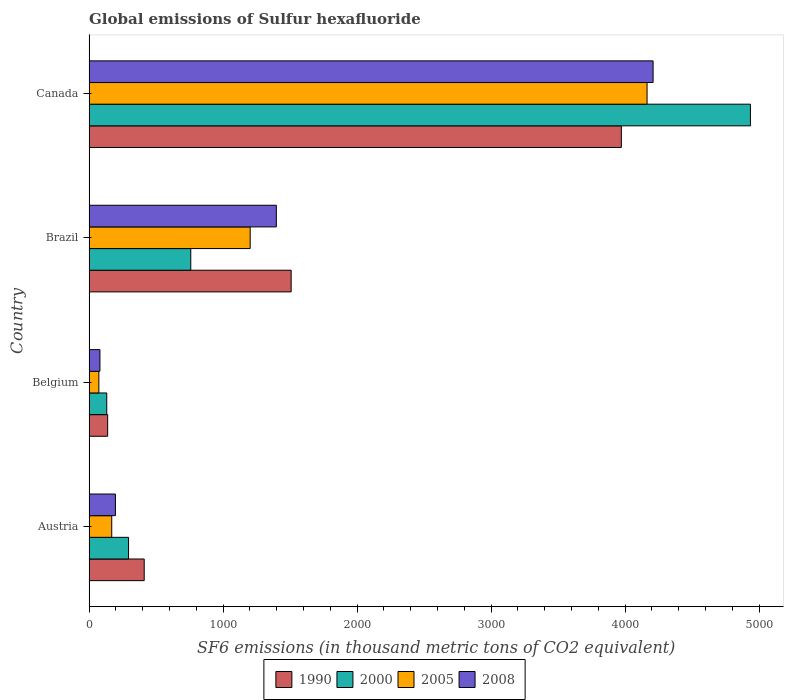How many groups of bars are there?
Your response must be concise. 4. Are the number of bars per tick equal to the number of legend labels?
Offer a terse response. Yes. How many bars are there on the 2nd tick from the bottom?
Offer a terse response. 4. What is the label of the 3rd group of bars from the top?
Make the answer very short. Belgium. In how many cases, is the number of bars for a given country not equal to the number of legend labels?
Provide a short and direct response. 0. What is the global emissions of Sulfur hexafluoride in 1990 in Austria?
Your answer should be compact. 411.2. Across all countries, what is the maximum global emissions of Sulfur hexafluoride in 1990?
Your answer should be compact. 3971.8. Across all countries, what is the minimum global emissions of Sulfur hexafluoride in 2008?
Offer a terse response. 80.9. In which country was the global emissions of Sulfur hexafluoride in 1990 minimum?
Provide a short and direct response. Belgium. What is the total global emissions of Sulfur hexafluoride in 1990 in the graph?
Offer a terse response. 6029.4. What is the difference between the global emissions of Sulfur hexafluoride in 2005 in Austria and that in Belgium?
Provide a succinct answer. 96.1. What is the difference between the global emissions of Sulfur hexafluoride in 2008 in Austria and the global emissions of Sulfur hexafluoride in 2005 in Canada?
Your answer should be very brief. -3967.4. What is the average global emissions of Sulfur hexafluoride in 1990 per country?
Ensure brevity in your answer.  1507.35. What is the difference between the global emissions of Sulfur hexafluoride in 1990 and global emissions of Sulfur hexafluoride in 2008 in Belgium?
Provide a succinct answer. 57.6. What is the ratio of the global emissions of Sulfur hexafluoride in 2000 in Belgium to that in Canada?
Give a very brief answer. 0.03. Is the global emissions of Sulfur hexafluoride in 2005 in Austria less than that in Brazil?
Your response must be concise. Yes. What is the difference between the highest and the second highest global emissions of Sulfur hexafluoride in 2005?
Your answer should be compact. 2961.8. What is the difference between the highest and the lowest global emissions of Sulfur hexafluoride in 2005?
Provide a short and direct response. 4090.9. Is the sum of the global emissions of Sulfur hexafluoride in 2005 in Brazil and Canada greater than the maximum global emissions of Sulfur hexafluoride in 2000 across all countries?
Offer a very short reply. Yes. Is it the case that in every country, the sum of the global emissions of Sulfur hexafluoride in 1990 and global emissions of Sulfur hexafluoride in 2000 is greater than the sum of global emissions of Sulfur hexafluoride in 2005 and global emissions of Sulfur hexafluoride in 2008?
Offer a terse response. No. What does the 1st bar from the top in Brazil represents?
Your answer should be compact. 2008. How many bars are there?
Your answer should be very brief. 16. Are all the bars in the graph horizontal?
Offer a terse response. Yes. What is the difference between two consecutive major ticks on the X-axis?
Keep it short and to the point. 1000. Does the graph contain grids?
Ensure brevity in your answer.  No. How are the legend labels stacked?
Offer a very short reply. Horizontal. What is the title of the graph?
Make the answer very short. Global emissions of Sulfur hexafluoride. What is the label or title of the X-axis?
Your answer should be compact. SF6 emissions (in thousand metric tons of CO2 equivalent). What is the SF6 emissions (in thousand metric tons of CO2 equivalent) of 1990 in Austria?
Your answer should be very brief. 411.2. What is the SF6 emissions (in thousand metric tons of CO2 equivalent) of 2000 in Austria?
Offer a very short reply. 294.4. What is the SF6 emissions (in thousand metric tons of CO2 equivalent) of 2005 in Austria?
Your answer should be compact. 169. What is the SF6 emissions (in thousand metric tons of CO2 equivalent) in 2008 in Austria?
Make the answer very short. 196.4. What is the SF6 emissions (in thousand metric tons of CO2 equivalent) of 1990 in Belgium?
Make the answer very short. 138.5. What is the SF6 emissions (in thousand metric tons of CO2 equivalent) of 2000 in Belgium?
Ensure brevity in your answer.  131.7. What is the SF6 emissions (in thousand metric tons of CO2 equivalent) of 2005 in Belgium?
Your response must be concise. 72.9. What is the SF6 emissions (in thousand metric tons of CO2 equivalent) of 2008 in Belgium?
Your response must be concise. 80.9. What is the SF6 emissions (in thousand metric tons of CO2 equivalent) in 1990 in Brazil?
Offer a very short reply. 1507.9. What is the SF6 emissions (in thousand metric tons of CO2 equivalent) of 2000 in Brazil?
Your answer should be very brief. 758.7. What is the SF6 emissions (in thousand metric tons of CO2 equivalent) in 2005 in Brazil?
Ensure brevity in your answer.  1202. What is the SF6 emissions (in thousand metric tons of CO2 equivalent) of 2008 in Brazil?
Offer a terse response. 1397.3. What is the SF6 emissions (in thousand metric tons of CO2 equivalent) in 1990 in Canada?
Offer a terse response. 3971.8. What is the SF6 emissions (in thousand metric tons of CO2 equivalent) of 2000 in Canada?
Your response must be concise. 4935.1. What is the SF6 emissions (in thousand metric tons of CO2 equivalent) of 2005 in Canada?
Give a very brief answer. 4163.8. What is the SF6 emissions (in thousand metric tons of CO2 equivalent) in 2008 in Canada?
Your answer should be very brief. 4208.8. Across all countries, what is the maximum SF6 emissions (in thousand metric tons of CO2 equivalent) in 1990?
Offer a terse response. 3971.8. Across all countries, what is the maximum SF6 emissions (in thousand metric tons of CO2 equivalent) of 2000?
Offer a very short reply. 4935.1. Across all countries, what is the maximum SF6 emissions (in thousand metric tons of CO2 equivalent) in 2005?
Offer a terse response. 4163.8. Across all countries, what is the maximum SF6 emissions (in thousand metric tons of CO2 equivalent) in 2008?
Give a very brief answer. 4208.8. Across all countries, what is the minimum SF6 emissions (in thousand metric tons of CO2 equivalent) of 1990?
Your answer should be compact. 138.5. Across all countries, what is the minimum SF6 emissions (in thousand metric tons of CO2 equivalent) of 2000?
Make the answer very short. 131.7. Across all countries, what is the minimum SF6 emissions (in thousand metric tons of CO2 equivalent) in 2005?
Your response must be concise. 72.9. Across all countries, what is the minimum SF6 emissions (in thousand metric tons of CO2 equivalent) in 2008?
Provide a succinct answer. 80.9. What is the total SF6 emissions (in thousand metric tons of CO2 equivalent) of 1990 in the graph?
Make the answer very short. 6029.4. What is the total SF6 emissions (in thousand metric tons of CO2 equivalent) of 2000 in the graph?
Your response must be concise. 6119.9. What is the total SF6 emissions (in thousand metric tons of CO2 equivalent) in 2005 in the graph?
Your response must be concise. 5607.7. What is the total SF6 emissions (in thousand metric tons of CO2 equivalent) in 2008 in the graph?
Offer a terse response. 5883.4. What is the difference between the SF6 emissions (in thousand metric tons of CO2 equivalent) of 1990 in Austria and that in Belgium?
Your answer should be compact. 272.7. What is the difference between the SF6 emissions (in thousand metric tons of CO2 equivalent) of 2000 in Austria and that in Belgium?
Offer a very short reply. 162.7. What is the difference between the SF6 emissions (in thousand metric tons of CO2 equivalent) of 2005 in Austria and that in Belgium?
Ensure brevity in your answer.  96.1. What is the difference between the SF6 emissions (in thousand metric tons of CO2 equivalent) of 2008 in Austria and that in Belgium?
Offer a terse response. 115.5. What is the difference between the SF6 emissions (in thousand metric tons of CO2 equivalent) of 1990 in Austria and that in Brazil?
Make the answer very short. -1096.7. What is the difference between the SF6 emissions (in thousand metric tons of CO2 equivalent) in 2000 in Austria and that in Brazil?
Provide a short and direct response. -464.3. What is the difference between the SF6 emissions (in thousand metric tons of CO2 equivalent) of 2005 in Austria and that in Brazil?
Your response must be concise. -1033. What is the difference between the SF6 emissions (in thousand metric tons of CO2 equivalent) in 2008 in Austria and that in Brazil?
Offer a very short reply. -1200.9. What is the difference between the SF6 emissions (in thousand metric tons of CO2 equivalent) of 1990 in Austria and that in Canada?
Ensure brevity in your answer.  -3560.6. What is the difference between the SF6 emissions (in thousand metric tons of CO2 equivalent) of 2000 in Austria and that in Canada?
Your answer should be compact. -4640.7. What is the difference between the SF6 emissions (in thousand metric tons of CO2 equivalent) in 2005 in Austria and that in Canada?
Keep it short and to the point. -3994.8. What is the difference between the SF6 emissions (in thousand metric tons of CO2 equivalent) of 2008 in Austria and that in Canada?
Your answer should be very brief. -4012.4. What is the difference between the SF6 emissions (in thousand metric tons of CO2 equivalent) of 1990 in Belgium and that in Brazil?
Your response must be concise. -1369.4. What is the difference between the SF6 emissions (in thousand metric tons of CO2 equivalent) in 2000 in Belgium and that in Brazil?
Provide a succinct answer. -627. What is the difference between the SF6 emissions (in thousand metric tons of CO2 equivalent) in 2005 in Belgium and that in Brazil?
Ensure brevity in your answer.  -1129.1. What is the difference between the SF6 emissions (in thousand metric tons of CO2 equivalent) of 2008 in Belgium and that in Brazil?
Keep it short and to the point. -1316.4. What is the difference between the SF6 emissions (in thousand metric tons of CO2 equivalent) in 1990 in Belgium and that in Canada?
Make the answer very short. -3833.3. What is the difference between the SF6 emissions (in thousand metric tons of CO2 equivalent) in 2000 in Belgium and that in Canada?
Offer a terse response. -4803.4. What is the difference between the SF6 emissions (in thousand metric tons of CO2 equivalent) of 2005 in Belgium and that in Canada?
Your response must be concise. -4090.9. What is the difference between the SF6 emissions (in thousand metric tons of CO2 equivalent) in 2008 in Belgium and that in Canada?
Ensure brevity in your answer.  -4127.9. What is the difference between the SF6 emissions (in thousand metric tons of CO2 equivalent) of 1990 in Brazil and that in Canada?
Offer a terse response. -2463.9. What is the difference between the SF6 emissions (in thousand metric tons of CO2 equivalent) in 2000 in Brazil and that in Canada?
Your response must be concise. -4176.4. What is the difference between the SF6 emissions (in thousand metric tons of CO2 equivalent) of 2005 in Brazil and that in Canada?
Keep it short and to the point. -2961.8. What is the difference between the SF6 emissions (in thousand metric tons of CO2 equivalent) in 2008 in Brazil and that in Canada?
Ensure brevity in your answer.  -2811.5. What is the difference between the SF6 emissions (in thousand metric tons of CO2 equivalent) in 1990 in Austria and the SF6 emissions (in thousand metric tons of CO2 equivalent) in 2000 in Belgium?
Your response must be concise. 279.5. What is the difference between the SF6 emissions (in thousand metric tons of CO2 equivalent) in 1990 in Austria and the SF6 emissions (in thousand metric tons of CO2 equivalent) in 2005 in Belgium?
Provide a short and direct response. 338.3. What is the difference between the SF6 emissions (in thousand metric tons of CO2 equivalent) in 1990 in Austria and the SF6 emissions (in thousand metric tons of CO2 equivalent) in 2008 in Belgium?
Provide a short and direct response. 330.3. What is the difference between the SF6 emissions (in thousand metric tons of CO2 equivalent) of 2000 in Austria and the SF6 emissions (in thousand metric tons of CO2 equivalent) of 2005 in Belgium?
Offer a terse response. 221.5. What is the difference between the SF6 emissions (in thousand metric tons of CO2 equivalent) of 2000 in Austria and the SF6 emissions (in thousand metric tons of CO2 equivalent) of 2008 in Belgium?
Make the answer very short. 213.5. What is the difference between the SF6 emissions (in thousand metric tons of CO2 equivalent) in 2005 in Austria and the SF6 emissions (in thousand metric tons of CO2 equivalent) in 2008 in Belgium?
Ensure brevity in your answer.  88.1. What is the difference between the SF6 emissions (in thousand metric tons of CO2 equivalent) in 1990 in Austria and the SF6 emissions (in thousand metric tons of CO2 equivalent) in 2000 in Brazil?
Provide a succinct answer. -347.5. What is the difference between the SF6 emissions (in thousand metric tons of CO2 equivalent) in 1990 in Austria and the SF6 emissions (in thousand metric tons of CO2 equivalent) in 2005 in Brazil?
Offer a terse response. -790.8. What is the difference between the SF6 emissions (in thousand metric tons of CO2 equivalent) of 1990 in Austria and the SF6 emissions (in thousand metric tons of CO2 equivalent) of 2008 in Brazil?
Give a very brief answer. -986.1. What is the difference between the SF6 emissions (in thousand metric tons of CO2 equivalent) of 2000 in Austria and the SF6 emissions (in thousand metric tons of CO2 equivalent) of 2005 in Brazil?
Ensure brevity in your answer.  -907.6. What is the difference between the SF6 emissions (in thousand metric tons of CO2 equivalent) in 2000 in Austria and the SF6 emissions (in thousand metric tons of CO2 equivalent) in 2008 in Brazil?
Provide a succinct answer. -1102.9. What is the difference between the SF6 emissions (in thousand metric tons of CO2 equivalent) of 2005 in Austria and the SF6 emissions (in thousand metric tons of CO2 equivalent) of 2008 in Brazil?
Give a very brief answer. -1228.3. What is the difference between the SF6 emissions (in thousand metric tons of CO2 equivalent) in 1990 in Austria and the SF6 emissions (in thousand metric tons of CO2 equivalent) in 2000 in Canada?
Keep it short and to the point. -4523.9. What is the difference between the SF6 emissions (in thousand metric tons of CO2 equivalent) in 1990 in Austria and the SF6 emissions (in thousand metric tons of CO2 equivalent) in 2005 in Canada?
Provide a succinct answer. -3752.6. What is the difference between the SF6 emissions (in thousand metric tons of CO2 equivalent) in 1990 in Austria and the SF6 emissions (in thousand metric tons of CO2 equivalent) in 2008 in Canada?
Keep it short and to the point. -3797.6. What is the difference between the SF6 emissions (in thousand metric tons of CO2 equivalent) of 2000 in Austria and the SF6 emissions (in thousand metric tons of CO2 equivalent) of 2005 in Canada?
Ensure brevity in your answer.  -3869.4. What is the difference between the SF6 emissions (in thousand metric tons of CO2 equivalent) in 2000 in Austria and the SF6 emissions (in thousand metric tons of CO2 equivalent) in 2008 in Canada?
Your response must be concise. -3914.4. What is the difference between the SF6 emissions (in thousand metric tons of CO2 equivalent) in 2005 in Austria and the SF6 emissions (in thousand metric tons of CO2 equivalent) in 2008 in Canada?
Provide a short and direct response. -4039.8. What is the difference between the SF6 emissions (in thousand metric tons of CO2 equivalent) in 1990 in Belgium and the SF6 emissions (in thousand metric tons of CO2 equivalent) in 2000 in Brazil?
Offer a terse response. -620.2. What is the difference between the SF6 emissions (in thousand metric tons of CO2 equivalent) of 1990 in Belgium and the SF6 emissions (in thousand metric tons of CO2 equivalent) of 2005 in Brazil?
Make the answer very short. -1063.5. What is the difference between the SF6 emissions (in thousand metric tons of CO2 equivalent) of 1990 in Belgium and the SF6 emissions (in thousand metric tons of CO2 equivalent) of 2008 in Brazil?
Offer a very short reply. -1258.8. What is the difference between the SF6 emissions (in thousand metric tons of CO2 equivalent) of 2000 in Belgium and the SF6 emissions (in thousand metric tons of CO2 equivalent) of 2005 in Brazil?
Ensure brevity in your answer.  -1070.3. What is the difference between the SF6 emissions (in thousand metric tons of CO2 equivalent) of 2000 in Belgium and the SF6 emissions (in thousand metric tons of CO2 equivalent) of 2008 in Brazil?
Offer a terse response. -1265.6. What is the difference between the SF6 emissions (in thousand metric tons of CO2 equivalent) of 2005 in Belgium and the SF6 emissions (in thousand metric tons of CO2 equivalent) of 2008 in Brazil?
Your answer should be very brief. -1324.4. What is the difference between the SF6 emissions (in thousand metric tons of CO2 equivalent) of 1990 in Belgium and the SF6 emissions (in thousand metric tons of CO2 equivalent) of 2000 in Canada?
Your answer should be very brief. -4796.6. What is the difference between the SF6 emissions (in thousand metric tons of CO2 equivalent) of 1990 in Belgium and the SF6 emissions (in thousand metric tons of CO2 equivalent) of 2005 in Canada?
Your response must be concise. -4025.3. What is the difference between the SF6 emissions (in thousand metric tons of CO2 equivalent) in 1990 in Belgium and the SF6 emissions (in thousand metric tons of CO2 equivalent) in 2008 in Canada?
Keep it short and to the point. -4070.3. What is the difference between the SF6 emissions (in thousand metric tons of CO2 equivalent) of 2000 in Belgium and the SF6 emissions (in thousand metric tons of CO2 equivalent) of 2005 in Canada?
Make the answer very short. -4032.1. What is the difference between the SF6 emissions (in thousand metric tons of CO2 equivalent) in 2000 in Belgium and the SF6 emissions (in thousand metric tons of CO2 equivalent) in 2008 in Canada?
Ensure brevity in your answer.  -4077.1. What is the difference between the SF6 emissions (in thousand metric tons of CO2 equivalent) of 2005 in Belgium and the SF6 emissions (in thousand metric tons of CO2 equivalent) of 2008 in Canada?
Ensure brevity in your answer.  -4135.9. What is the difference between the SF6 emissions (in thousand metric tons of CO2 equivalent) of 1990 in Brazil and the SF6 emissions (in thousand metric tons of CO2 equivalent) of 2000 in Canada?
Ensure brevity in your answer.  -3427.2. What is the difference between the SF6 emissions (in thousand metric tons of CO2 equivalent) of 1990 in Brazil and the SF6 emissions (in thousand metric tons of CO2 equivalent) of 2005 in Canada?
Make the answer very short. -2655.9. What is the difference between the SF6 emissions (in thousand metric tons of CO2 equivalent) in 1990 in Brazil and the SF6 emissions (in thousand metric tons of CO2 equivalent) in 2008 in Canada?
Your answer should be very brief. -2700.9. What is the difference between the SF6 emissions (in thousand metric tons of CO2 equivalent) of 2000 in Brazil and the SF6 emissions (in thousand metric tons of CO2 equivalent) of 2005 in Canada?
Keep it short and to the point. -3405.1. What is the difference between the SF6 emissions (in thousand metric tons of CO2 equivalent) of 2000 in Brazil and the SF6 emissions (in thousand metric tons of CO2 equivalent) of 2008 in Canada?
Make the answer very short. -3450.1. What is the difference between the SF6 emissions (in thousand metric tons of CO2 equivalent) in 2005 in Brazil and the SF6 emissions (in thousand metric tons of CO2 equivalent) in 2008 in Canada?
Keep it short and to the point. -3006.8. What is the average SF6 emissions (in thousand metric tons of CO2 equivalent) in 1990 per country?
Ensure brevity in your answer.  1507.35. What is the average SF6 emissions (in thousand metric tons of CO2 equivalent) in 2000 per country?
Provide a short and direct response. 1529.97. What is the average SF6 emissions (in thousand metric tons of CO2 equivalent) in 2005 per country?
Your answer should be compact. 1401.92. What is the average SF6 emissions (in thousand metric tons of CO2 equivalent) in 2008 per country?
Your answer should be compact. 1470.85. What is the difference between the SF6 emissions (in thousand metric tons of CO2 equivalent) in 1990 and SF6 emissions (in thousand metric tons of CO2 equivalent) in 2000 in Austria?
Offer a terse response. 116.8. What is the difference between the SF6 emissions (in thousand metric tons of CO2 equivalent) of 1990 and SF6 emissions (in thousand metric tons of CO2 equivalent) of 2005 in Austria?
Provide a short and direct response. 242.2. What is the difference between the SF6 emissions (in thousand metric tons of CO2 equivalent) of 1990 and SF6 emissions (in thousand metric tons of CO2 equivalent) of 2008 in Austria?
Provide a succinct answer. 214.8. What is the difference between the SF6 emissions (in thousand metric tons of CO2 equivalent) in 2000 and SF6 emissions (in thousand metric tons of CO2 equivalent) in 2005 in Austria?
Offer a terse response. 125.4. What is the difference between the SF6 emissions (in thousand metric tons of CO2 equivalent) of 2000 and SF6 emissions (in thousand metric tons of CO2 equivalent) of 2008 in Austria?
Provide a succinct answer. 98. What is the difference between the SF6 emissions (in thousand metric tons of CO2 equivalent) in 2005 and SF6 emissions (in thousand metric tons of CO2 equivalent) in 2008 in Austria?
Offer a terse response. -27.4. What is the difference between the SF6 emissions (in thousand metric tons of CO2 equivalent) in 1990 and SF6 emissions (in thousand metric tons of CO2 equivalent) in 2005 in Belgium?
Your answer should be very brief. 65.6. What is the difference between the SF6 emissions (in thousand metric tons of CO2 equivalent) in 1990 and SF6 emissions (in thousand metric tons of CO2 equivalent) in 2008 in Belgium?
Offer a very short reply. 57.6. What is the difference between the SF6 emissions (in thousand metric tons of CO2 equivalent) of 2000 and SF6 emissions (in thousand metric tons of CO2 equivalent) of 2005 in Belgium?
Offer a very short reply. 58.8. What is the difference between the SF6 emissions (in thousand metric tons of CO2 equivalent) of 2000 and SF6 emissions (in thousand metric tons of CO2 equivalent) of 2008 in Belgium?
Ensure brevity in your answer.  50.8. What is the difference between the SF6 emissions (in thousand metric tons of CO2 equivalent) of 2005 and SF6 emissions (in thousand metric tons of CO2 equivalent) of 2008 in Belgium?
Provide a short and direct response. -8. What is the difference between the SF6 emissions (in thousand metric tons of CO2 equivalent) in 1990 and SF6 emissions (in thousand metric tons of CO2 equivalent) in 2000 in Brazil?
Keep it short and to the point. 749.2. What is the difference between the SF6 emissions (in thousand metric tons of CO2 equivalent) of 1990 and SF6 emissions (in thousand metric tons of CO2 equivalent) of 2005 in Brazil?
Provide a short and direct response. 305.9. What is the difference between the SF6 emissions (in thousand metric tons of CO2 equivalent) of 1990 and SF6 emissions (in thousand metric tons of CO2 equivalent) of 2008 in Brazil?
Keep it short and to the point. 110.6. What is the difference between the SF6 emissions (in thousand metric tons of CO2 equivalent) in 2000 and SF6 emissions (in thousand metric tons of CO2 equivalent) in 2005 in Brazil?
Make the answer very short. -443.3. What is the difference between the SF6 emissions (in thousand metric tons of CO2 equivalent) in 2000 and SF6 emissions (in thousand metric tons of CO2 equivalent) in 2008 in Brazil?
Keep it short and to the point. -638.6. What is the difference between the SF6 emissions (in thousand metric tons of CO2 equivalent) of 2005 and SF6 emissions (in thousand metric tons of CO2 equivalent) of 2008 in Brazil?
Your answer should be very brief. -195.3. What is the difference between the SF6 emissions (in thousand metric tons of CO2 equivalent) of 1990 and SF6 emissions (in thousand metric tons of CO2 equivalent) of 2000 in Canada?
Make the answer very short. -963.3. What is the difference between the SF6 emissions (in thousand metric tons of CO2 equivalent) in 1990 and SF6 emissions (in thousand metric tons of CO2 equivalent) in 2005 in Canada?
Offer a terse response. -192. What is the difference between the SF6 emissions (in thousand metric tons of CO2 equivalent) in 1990 and SF6 emissions (in thousand metric tons of CO2 equivalent) in 2008 in Canada?
Give a very brief answer. -237. What is the difference between the SF6 emissions (in thousand metric tons of CO2 equivalent) of 2000 and SF6 emissions (in thousand metric tons of CO2 equivalent) of 2005 in Canada?
Make the answer very short. 771.3. What is the difference between the SF6 emissions (in thousand metric tons of CO2 equivalent) of 2000 and SF6 emissions (in thousand metric tons of CO2 equivalent) of 2008 in Canada?
Ensure brevity in your answer.  726.3. What is the difference between the SF6 emissions (in thousand metric tons of CO2 equivalent) of 2005 and SF6 emissions (in thousand metric tons of CO2 equivalent) of 2008 in Canada?
Keep it short and to the point. -45. What is the ratio of the SF6 emissions (in thousand metric tons of CO2 equivalent) of 1990 in Austria to that in Belgium?
Your response must be concise. 2.97. What is the ratio of the SF6 emissions (in thousand metric tons of CO2 equivalent) in 2000 in Austria to that in Belgium?
Keep it short and to the point. 2.24. What is the ratio of the SF6 emissions (in thousand metric tons of CO2 equivalent) in 2005 in Austria to that in Belgium?
Your answer should be very brief. 2.32. What is the ratio of the SF6 emissions (in thousand metric tons of CO2 equivalent) in 2008 in Austria to that in Belgium?
Offer a very short reply. 2.43. What is the ratio of the SF6 emissions (in thousand metric tons of CO2 equivalent) of 1990 in Austria to that in Brazil?
Your answer should be very brief. 0.27. What is the ratio of the SF6 emissions (in thousand metric tons of CO2 equivalent) in 2000 in Austria to that in Brazil?
Provide a succinct answer. 0.39. What is the ratio of the SF6 emissions (in thousand metric tons of CO2 equivalent) of 2005 in Austria to that in Brazil?
Offer a terse response. 0.14. What is the ratio of the SF6 emissions (in thousand metric tons of CO2 equivalent) of 2008 in Austria to that in Brazil?
Provide a short and direct response. 0.14. What is the ratio of the SF6 emissions (in thousand metric tons of CO2 equivalent) in 1990 in Austria to that in Canada?
Offer a very short reply. 0.1. What is the ratio of the SF6 emissions (in thousand metric tons of CO2 equivalent) of 2000 in Austria to that in Canada?
Give a very brief answer. 0.06. What is the ratio of the SF6 emissions (in thousand metric tons of CO2 equivalent) of 2005 in Austria to that in Canada?
Keep it short and to the point. 0.04. What is the ratio of the SF6 emissions (in thousand metric tons of CO2 equivalent) of 2008 in Austria to that in Canada?
Offer a very short reply. 0.05. What is the ratio of the SF6 emissions (in thousand metric tons of CO2 equivalent) of 1990 in Belgium to that in Brazil?
Offer a terse response. 0.09. What is the ratio of the SF6 emissions (in thousand metric tons of CO2 equivalent) of 2000 in Belgium to that in Brazil?
Make the answer very short. 0.17. What is the ratio of the SF6 emissions (in thousand metric tons of CO2 equivalent) of 2005 in Belgium to that in Brazil?
Offer a very short reply. 0.06. What is the ratio of the SF6 emissions (in thousand metric tons of CO2 equivalent) of 2008 in Belgium to that in Brazil?
Your response must be concise. 0.06. What is the ratio of the SF6 emissions (in thousand metric tons of CO2 equivalent) in 1990 in Belgium to that in Canada?
Offer a terse response. 0.03. What is the ratio of the SF6 emissions (in thousand metric tons of CO2 equivalent) of 2000 in Belgium to that in Canada?
Offer a very short reply. 0.03. What is the ratio of the SF6 emissions (in thousand metric tons of CO2 equivalent) in 2005 in Belgium to that in Canada?
Your response must be concise. 0.02. What is the ratio of the SF6 emissions (in thousand metric tons of CO2 equivalent) in 2008 in Belgium to that in Canada?
Offer a terse response. 0.02. What is the ratio of the SF6 emissions (in thousand metric tons of CO2 equivalent) in 1990 in Brazil to that in Canada?
Your response must be concise. 0.38. What is the ratio of the SF6 emissions (in thousand metric tons of CO2 equivalent) in 2000 in Brazil to that in Canada?
Your answer should be compact. 0.15. What is the ratio of the SF6 emissions (in thousand metric tons of CO2 equivalent) in 2005 in Brazil to that in Canada?
Ensure brevity in your answer.  0.29. What is the ratio of the SF6 emissions (in thousand metric tons of CO2 equivalent) in 2008 in Brazil to that in Canada?
Keep it short and to the point. 0.33. What is the difference between the highest and the second highest SF6 emissions (in thousand metric tons of CO2 equivalent) in 1990?
Make the answer very short. 2463.9. What is the difference between the highest and the second highest SF6 emissions (in thousand metric tons of CO2 equivalent) of 2000?
Make the answer very short. 4176.4. What is the difference between the highest and the second highest SF6 emissions (in thousand metric tons of CO2 equivalent) in 2005?
Give a very brief answer. 2961.8. What is the difference between the highest and the second highest SF6 emissions (in thousand metric tons of CO2 equivalent) of 2008?
Ensure brevity in your answer.  2811.5. What is the difference between the highest and the lowest SF6 emissions (in thousand metric tons of CO2 equivalent) in 1990?
Ensure brevity in your answer.  3833.3. What is the difference between the highest and the lowest SF6 emissions (in thousand metric tons of CO2 equivalent) in 2000?
Offer a very short reply. 4803.4. What is the difference between the highest and the lowest SF6 emissions (in thousand metric tons of CO2 equivalent) in 2005?
Provide a succinct answer. 4090.9. What is the difference between the highest and the lowest SF6 emissions (in thousand metric tons of CO2 equivalent) in 2008?
Ensure brevity in your answer.  4127.9. 